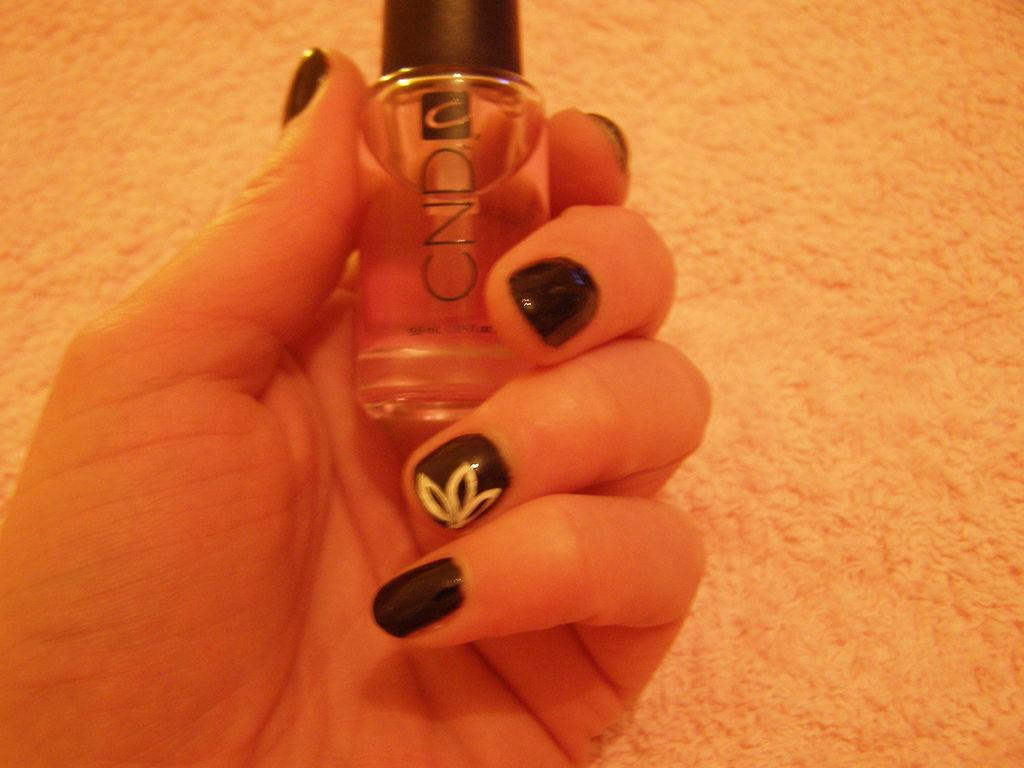<image>
Render a clear and concise summary of the photo. A woman holds a bottle of CND nail polish. 